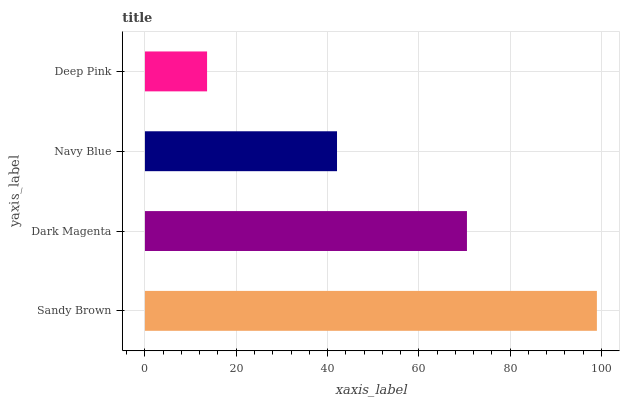Is Deep Pink the minimum?
Answer yes or no. Yes. Is Sandy Brown the maximum?
Answer yes or no. Yes. Is Dark Magenta the minimum?
Answer yes or no. No. Is Dark Magenta the maximum?
Answer yes or no. No. Is Sandy Brown greater than Dark Magenta?
Answer yes or no. Yes. Is Dark Magenta less than Sandy Brown?
Answer yes or no. Yes. Is Dark Magenta greater than Sandy Brown?
Answer yes or no. No. Is Sandy Brown less than Dark Magenta?
Answer yes or no. No. Is Dark Magenta the high median?
Answer yes or no. Yes. Is Navy Blue the low median?
Answer yes or no. Yes. Is Navy Blue the high median?
Answer yes or no. No. Is Deep Pink the low median?
Answer yes or no. No. 